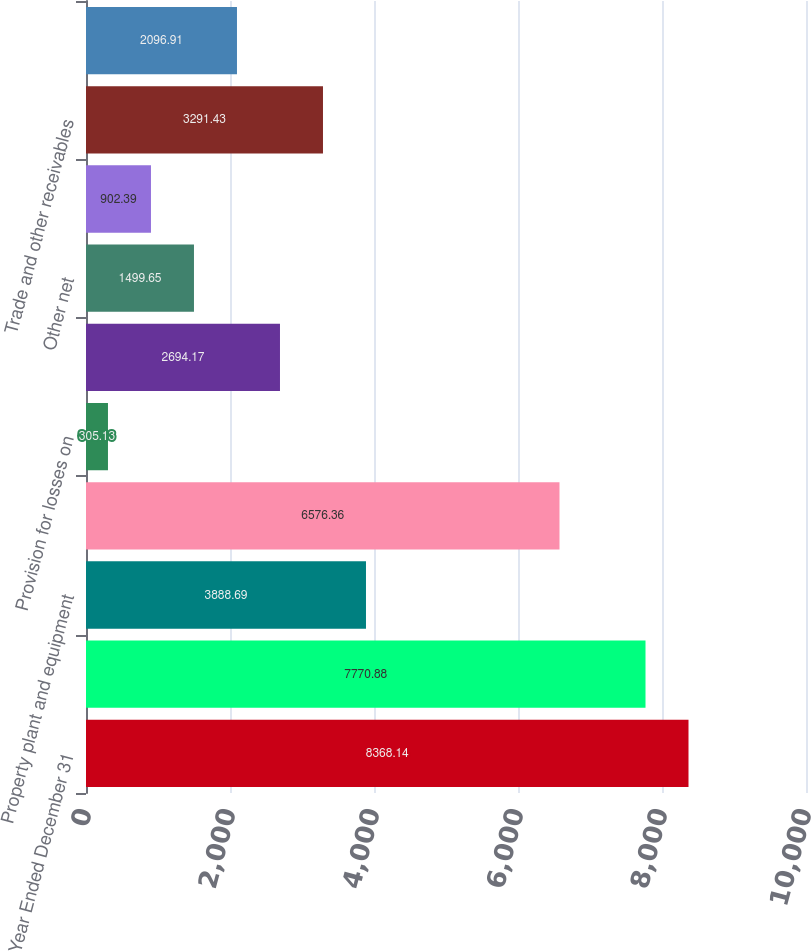<chart> <loc_0><loc_0><loc_500><loc_500><bar_chart><fcel>Year Ended December 31<fcel>Net Income<fcel>Property plant and equipment<fcel>Equipment on operating leases<fcel>Provision for losses on<fcel>Deferred taxes<fcel>Other net<fcel>Pension contributions<fcel>Trade and other receivables<fcel>Wholesale receivables on new<nl><fcel>8368.14<fcel>7770.88<fcel>3888.69<fcel>6576.36<fcel>305.13<fcel>2694.17<fcel>1499.65<fcel>902.39<fcel>3291.43<fcel>2096.91<nl></chart> 